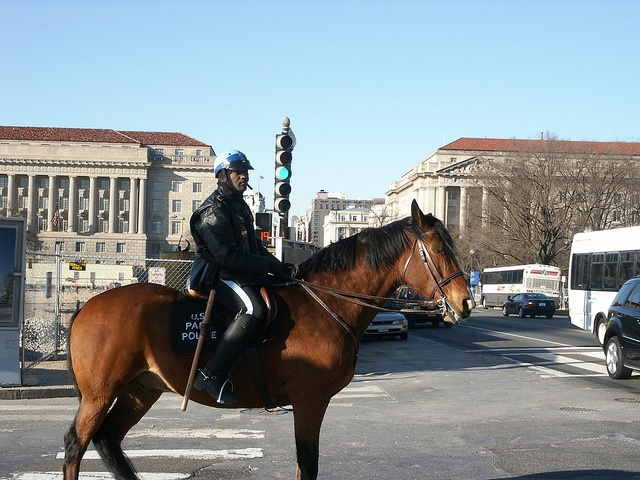Describe the objects in this image and their specific colors. I can see horse in lightblue, black, maroon, brown, and gray tones, people in lightblue, black, gray, white, and navy tones, bus in lightblue, white, black, gray, and darkgray tones, car in lightblue, black, and gray tones, and bus in lightblue, white, darkgray, gray, and black tones in this image. 